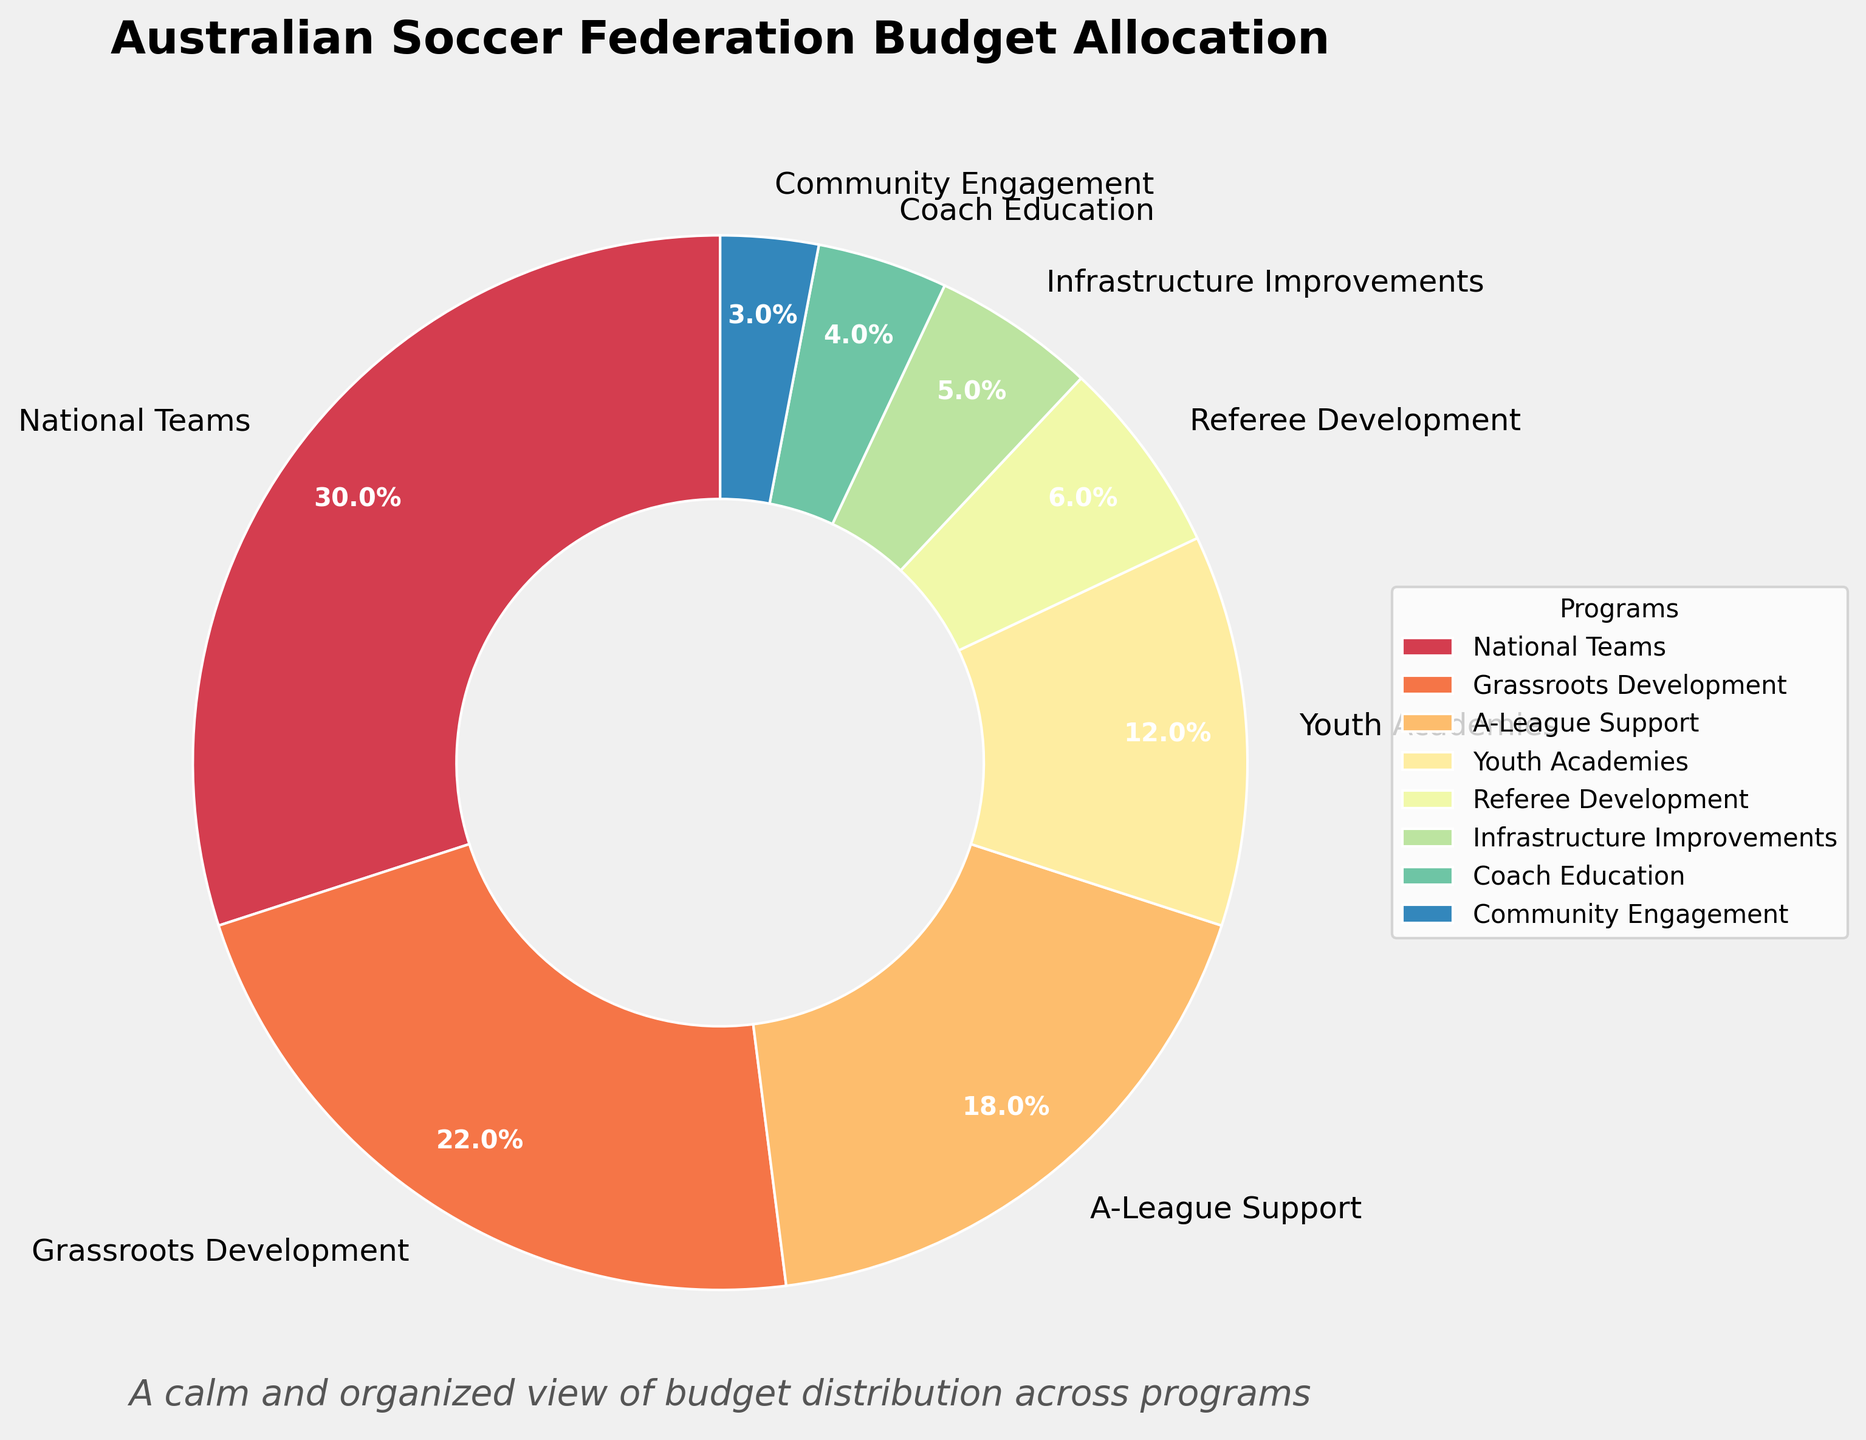What is the highest budget allocation percentage, and which program does it correspond to? The National Teams program has the highest budget allocation percentage at 30%. This can be determined by looking at the chart and identifying the largest slice.
Answer: National Teams, 30% Which program has a higher budget allocation: Grassroots Development or A-League Support? The Grassroots Development program has a budget allocation of 22%, while A-League Support has 18%. By comparing these two values, it is clear that Grassroots Development has a higher allocation.
Answer: Grassroots Development Sum the budget allocations for Youth Academies and Grassroots Development programs. Youth Academies have a 12% allocation, and Grassroots Development has 22%. Adding these together: 12% + 22% = 34%.
Answer: 34% What is the combined budget allocation for Infrastructure Improvements, Coach Education, and Community Engagement? Infrastructure Improvements have a 5% allocation, Coach Education has 4%, and Community Engagement has 3%. Adding these: 5% + 4% + 3% = 12%.
Answer: 12% Which programs have a budget allocation of less than 10%? By examining the smaller slices of the pie chart, the programs with less than 10% are Referee Development (6%), Infrastructure Improvements (5%), Coach Education (4%), and Community Engagement (3%).
Answer: Referee Development, Infrastructure Improvements, Coach Education, Community Engagement How much more budget allocation does the National Teams program have compared to the Youth Academies program? National Teams have a 30% allocation, while Youth Academies have 12%. The difference between these allocations is: 30% - 12% = 18%.
Answer: 18% What fraction of the total budget is allocated to programs other than National Teams? National Teams have a 30% allocation. Therefore, the allocation for other programs is: 100% - 30% = 70%.
Answer: 70% If the Youth Academies and Referee Development were combined into a single program, what would be their total budget allocation? Youth Academies have a 12% allocation, and Referee Development has 6%. Combining these: 12% + 6% = 18%.
Answer: 18% How does the allocation for Grassroots Development compare to the combined allocation for Referee Development and Infrastructure Improvements? Grassroots Development has a 22% allocation. Referee Development and Infrastructure Improvements together have: 6% + 5% = 11%. Thus, Grassroots Development has a higher allocation.
Answer: Grassroots Development has a higher allocation What is the total budget allocation for the top three programs? The top three programs are National Teams (30%), Grassroots Development (22%), and A-League Support (18%). Summing these: 30% + 22% + 18% = 70%.
Answer: 70% 